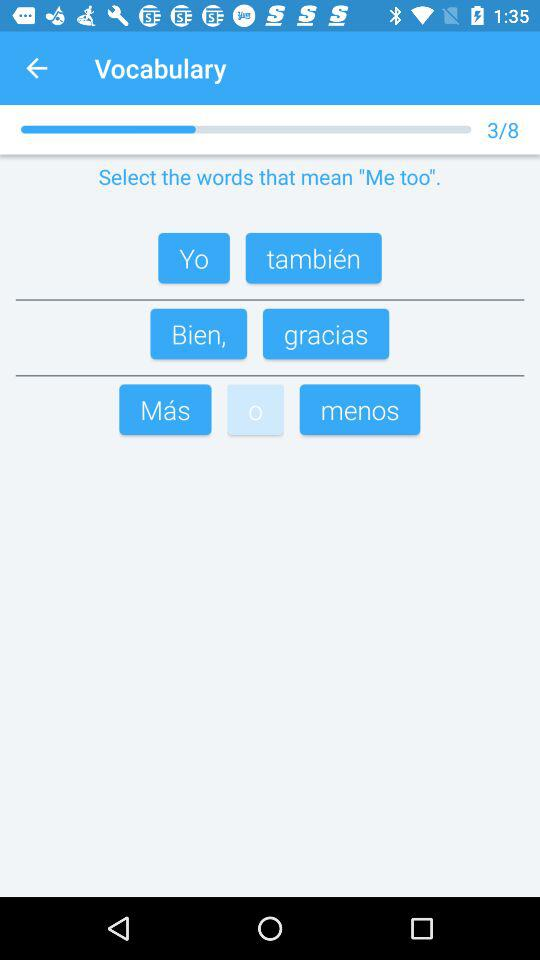What vocabulary quiz am I on right now? You are on the third vocabulary quiz. 